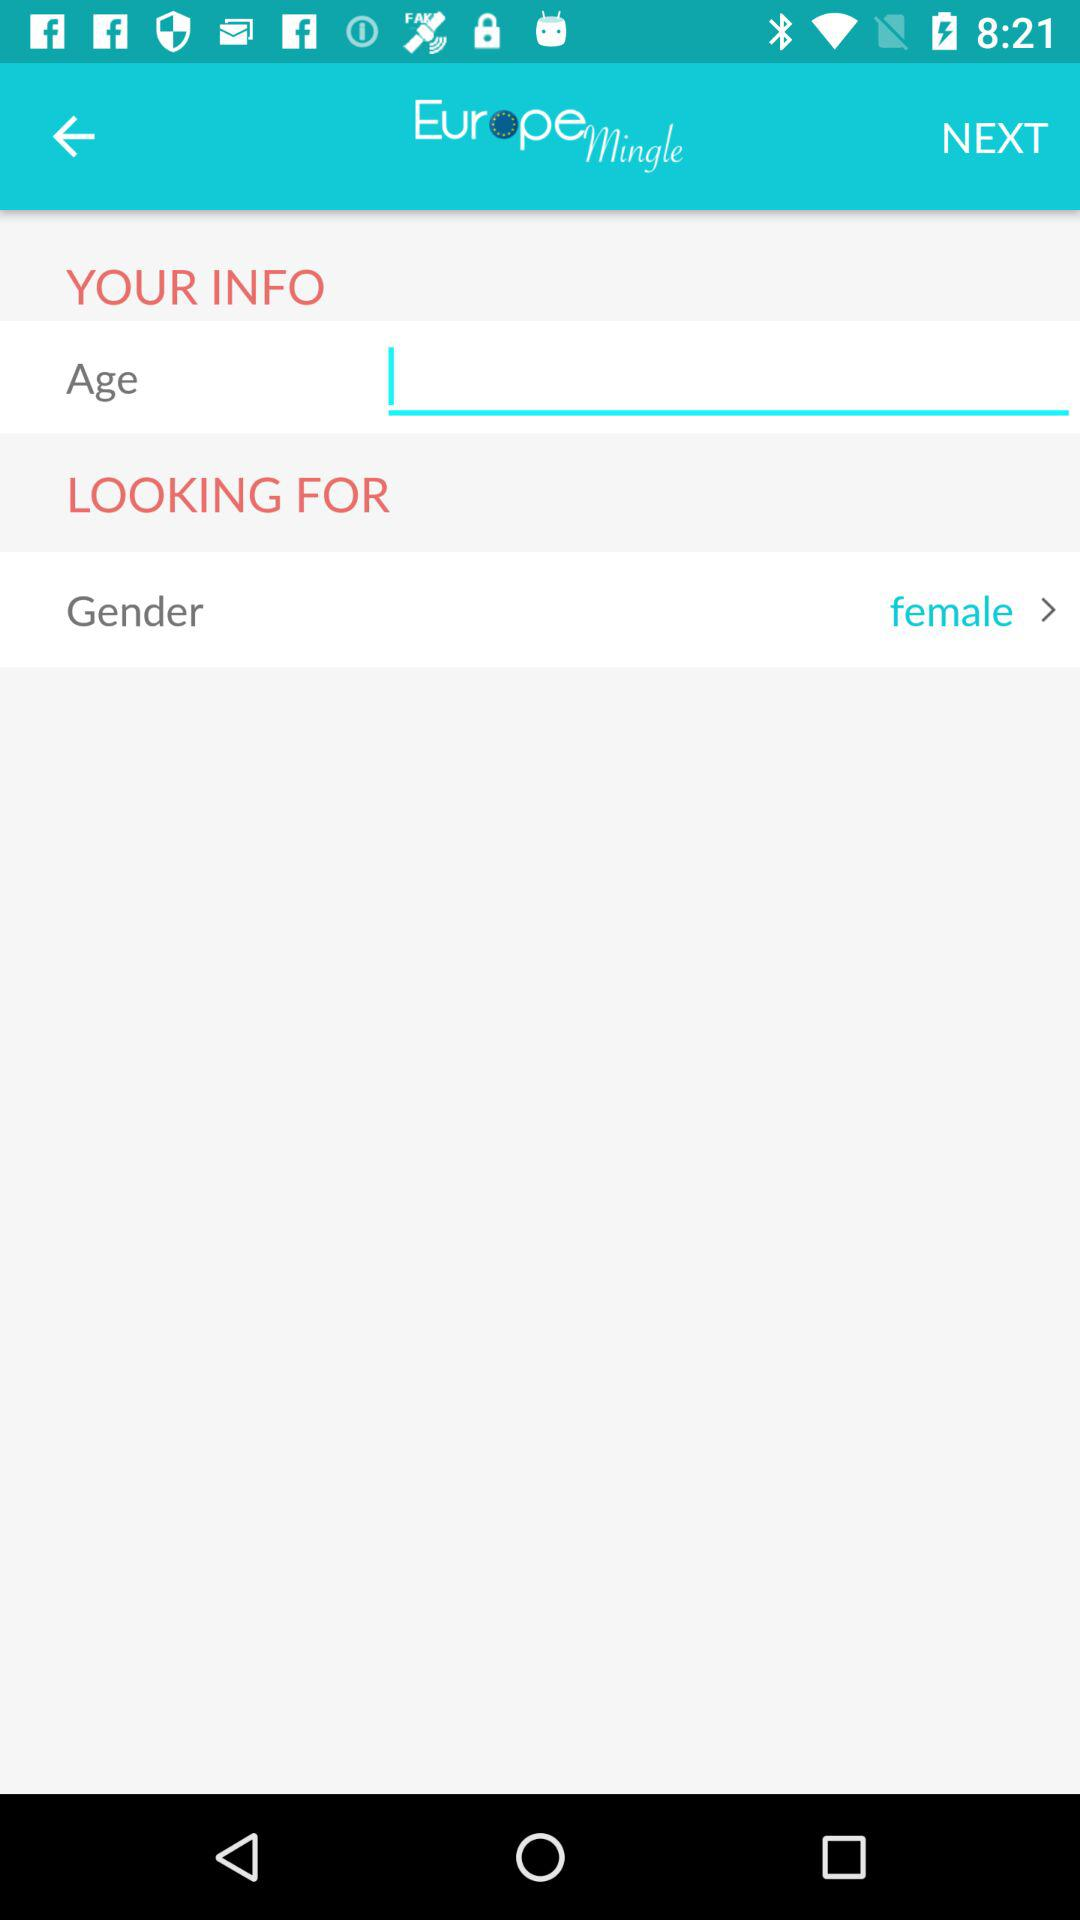Which gender is selected? The selected gender is female. 